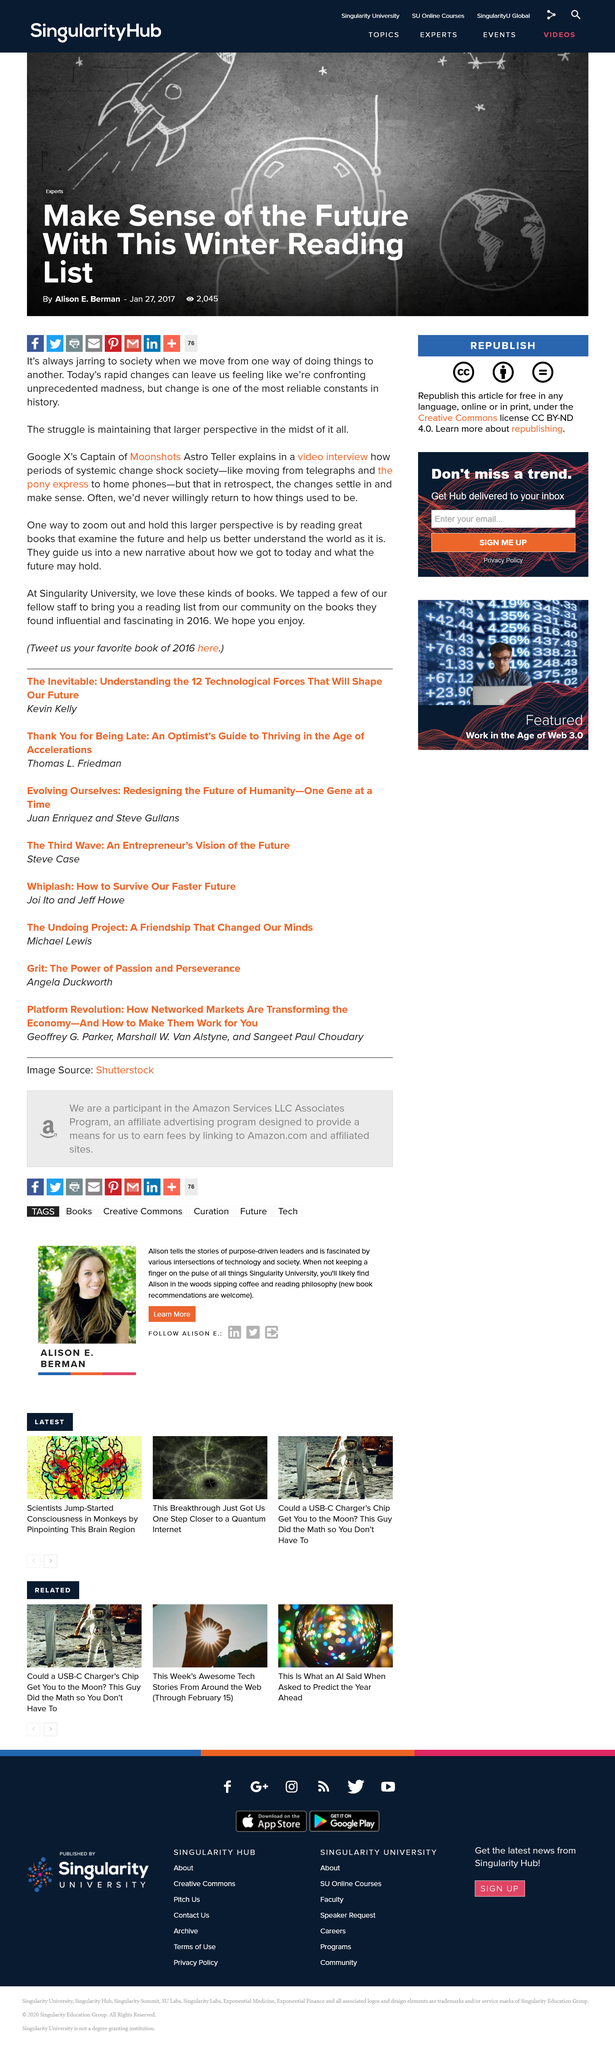List a handful of essential elements in this visual. Astro Teller is the Captain of Moonshots at Google X. This writing is the work of Alison E. Berman. This article has been viewed a total of 2,045 times. 